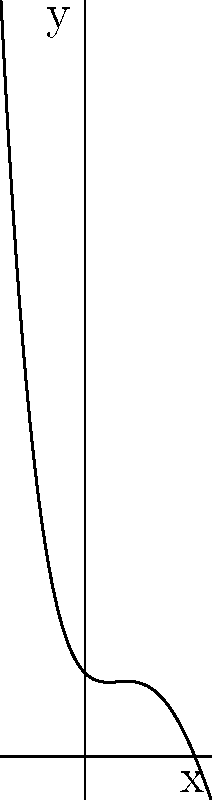The polynomial curve shown in the graph resembles Onyeka Onwenu's iconic hairstyle from her early career. Which of the following best describes the degree and leading coefficient of this polynomial function? To determine the degree and leading coefficient of the polynomial, let's analyze the graph:

1. The curve has three turning points (two local maxima and one local minimum), which suggests a polynomial of at least degree 3.

2. As x approaches positive or negative infinity, both ends of the curve rise upward, indicating an even-degree polynomial with a positive leading coefficient.

3. The curve's shape is more complex than a cubic function, which typically has only two turning points.

4. Given the information from steps 1-3, we can conclude that this is likely a 4th-degree polynomial (quartic) with a positive leading coefficient.

5. The positive leading coefficient is evident from the upward curve at both ends, and it appears to be a relatively small value (less than 1) due to the gradual rise of the curve.

Therefore, the polynomial function that best represents Onyeka Onwenu's iconic hairstyle in this graph is likely of degree 4 with a small positive leading coefficient.
Answer: 4th degree, small positive leading coefficient 